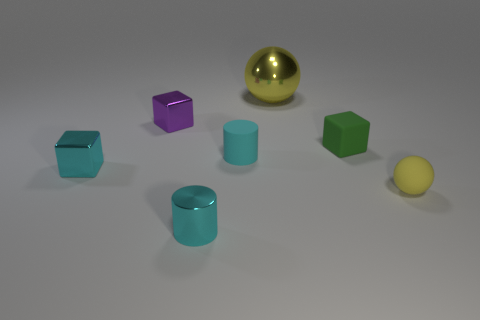There is a matte block that is the same size as the rubber cylinder; what is its color?
Make the answer very short. Green. There is a yellow ball in front of the tiny thing that is behind the green thing; is there a yellow thing behind it?
Give a very brief answer. Yes. What is the material of the cyan object that is on the left side of the cyan metal cylinder?
Provide a succinct answer. Metal. There is a cyan matte thing; is its shape the same as the small thing that is in front of the small yellow thing?
Your response must be concise. Yes. Are there the same number of cylinders that are behind the green cube and spheres that are on the left side of the tiny cyan matte object?
Make the answer very short. Yes. How many other objects are there of the same material as the tiny green object?
Your answer should be compact. 2. What number of shiny things are yellow things or tiny cylinders?
Give a very brief answer. 2. Is the shape of the yellow shiny object behind the tiny yellow rubber sphere the same as  the green rubber thing?
Your response must be concise. No. Are there more tiny cubes to the left of the large yellow shiny sphere than yellow matte spheres?
Ensure brevity in your answer.  Yes. What number of small cubes are both left of the shiny cylinder and on the right side of the cyan shiny cylinder?
Your answer should be very brief. 0. 